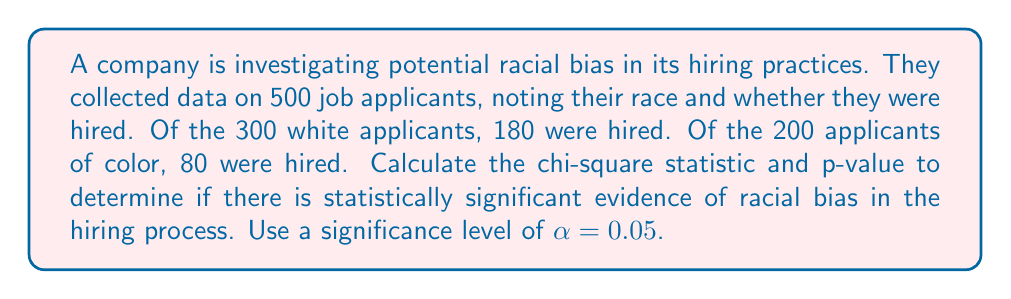Provide a solution to this math problem. To determine if there is statistically significant evidence of racial bias in hiring, we'll use a chi-square test of independence.

Step 1: Set up the observed frequency table
White applicants: 180 hired, 120 not hired
Applicants of color: 80 hired, 120 not hired

Step 2: Calculate expected frequencies
Total hired: 180 + 80 = 260
Total not hired: 120 + 120 = 240
Total applicants: 500

Expected frequencies:
White hired: $E_{11} = \frac{300 \times 260}{500} = 156$
White not hired: $E_{12} = \frac{300 \times 240}{500} = 144$
Color hired: $E_{21} = \frac{200 \times 260}{500} = 104$
Color not hired: $E_{22} = \frac{200 \times 240}{500} = 96$

Step 3: Calculate the chi-square statistic
$$\chi^2 = \sum \frac{(O - E)^2}{E}$$

$$\chi^2 = \frac{(180 - 156)^2}{156} + \frac{(120 - 144)^2}{144} + \frac{(80 - 104)^2}{104} + \frac{(120 - 96)^2}{96}$$

$$\chi^2 = 3.69 + 4.00 + 5.54 + 6.00 = 19.23$$

Step 4: Determine degrees of freedom
df = (rows - 1)(columns - 1) = (2 - 1)(2 - 1) = 1

Step 5: Find the critical value
For α = 0.05 and df = 1, the critical value is 3.841

Step 6: Calculate the p-value
Using a chi-square distribution calculator, we find that for χ² = 19.23 and df = 1, p < 0.0001

Step 7: Make a decision
Since χ² > critical value (19.23 > 3.841) and p < α (p < 0.0001 < 0.05), we reject the null hypothesis.
Answer: χ² = 19.23, p < 0.0001. There is statistically significant evidence of racial bias in the hiring process. 